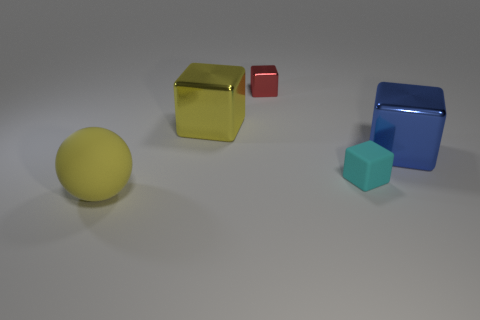Add 2 red things. How many objects exist? 7 Subtract all blocks. How many objects are left? 1 Subtract 0 purple cubes. How many objects are left? 5 Subtract all cyan matte cylinders. Subtract all large blocks. How many objects are left? 3 Add 2 cyan rubber cubes. How many cyan rubber cubes are left? 3 Add 2 big metal blocks. How many big metal blocks exist? 4 